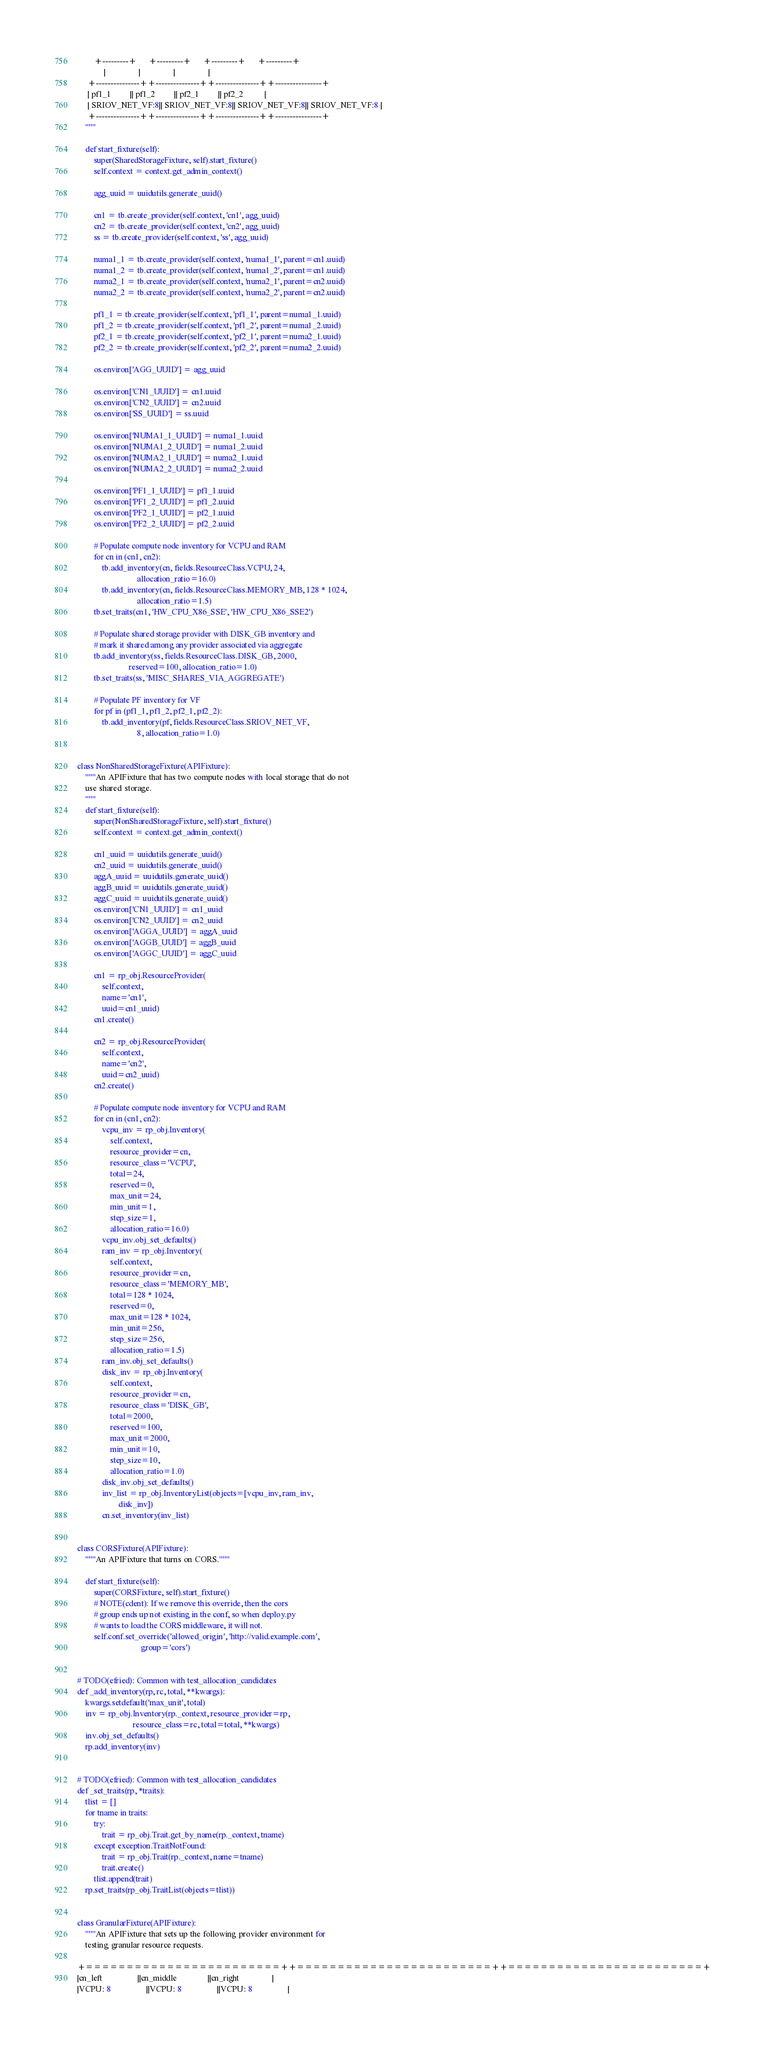Convert code to text. <code><loc_0><loc_0><loc_500><loc_500><_Python_>        +---------+      +---------+      +---------+      +---------+
             |                |                |                |
     +---------------++---------------++---------------++----------------+
     | pf1_1         || pf1_2         || pf2_1         || pf2_2          |
     | SRIOV_NET_VF:8|| SRIOV_NET_VF:8|| SRIOV_NET_VF:8|| SRIOV_NET_VF:8 |
     +---------------++---------------++---------------++----------------+
    """

    def start_fixture(self):
        super(SharedStorageFixture, self).start_fixture()
        self.context = context.get_admin_context()

        agg_uuid = uuidutils.generate_uuid()

        cn1 = tb.create_provider(self.context, 'cn1', agg_uuid)
        cn2 = tb.create_provider(self.context, 'cn2', agg_uuid)
        ss = tb.create_provider(self.context, 'ss', agg_uuid)

        numa1_1 = tb.create_provider(self.context, 'numa1_1', parent=cn1.uuid)
        numa1_2 = tb.create_provider(self.context, 'numa1_2', parent=cn1.uuid)
        numa2_1 = tb.create_provider(self.context, 'numa2_1', parent=cn2.uuid)
        numa2_2 = tb.create_provider(self.context, 'numa2_2', parent=cn2.uuid)

        pf1_1 = tb.create_provider(self.context, 'pf1_1', parent=numa1_1.uuid)
        pf1_2 = tb.create_provider(self.context, 'pf1_2', parent=numa1_2.uuid)
        pf2_1 = tb.create_provider(self.context, 'pf2_1', parent=numa2_1.uuid)
        pf2_2 = tb.create_provider(self.context, 'pf2_2', parent=numa2_2.uuid)

        os.environ['AGG_UUID'] = agg_uuid

        os.environ['CN1_UUID'] = cn1.uuid
        os.environ['CN2_UUID'] = cn2.uuid
        os.environ['SS_UUID'] = ss.uuid

        os.environ['NUMA1_1_UUID'] = numa1_1.uuid
        os.environ['NUMA1_2_UUID'] = numa1_2.uuid
        os.environ['NUMA2_1_UUID'] = numa2_1.uuid
        os.environ['NUMA2_2_UUID'] = numa2_2.uuid

        os.environ['PF1_1_UUID'] = pf1_1.uuid
        os.environ['PF1_2_UUID'] = pf1_2.uuid
        os.environ['PF2_1_UUID'] = pf2_1.uuid
        os.environ['PF2_2_UUID'] = pf2_2.uuid

        # Populate compute node inventory for VCPU and RAM
        for cn in (cn1, cn2):
            tb.add_inventory(cn, fields.ResourceClass.VCPU, 24,
                             allocation_ratio=16.0)
            tb.add_inventory(cn, fields.ResourceClass.MEMORY_MB, 128 * 1024,
                             allocation_ratio=1.5)
        tb.set_traits(cn1, 'HW_CPU_X86_SSE', 'HW_CPU_X86_SSE2')

        # Populate shared storage provider with DISK_GB inventory and
        # mark it shared among any provider associated via aggregate
        tb.add_inventory(ss, fields.ResourceClass.DISK_GB, 2000,
                         reserved=100, allocation_ratio=1.0)
        tb.set_traits(ss, 'MISC_SHARES_VIA_AGGREGATE')

        # Populate PF inventory for VF
        for pf in (pf1_1, pf1_2, pf2_1, pf2_2):
            tb.add_inventory(pf, fields.ResourceClass.SRIOV_NET_VF,
                             8, allocation_ratio=1.0)


class NonSharedStorageFixture(APIFixture):
    """An APIFixture that has two compute nodes with local storage that do not
    use shared storage.
    """
    def start_fixture(self):
        super(NonSharedStorageFixture, self).start_fixture()
        self.context = context.get_admin_context()

        cn1_uuid = uuidutils.generate_uuid()
        cn2_uuid = uuidutils.generate_uuid()
        aggA_uuid = uuidutils.generate_uuid()
        aggB_uuid = uuidutils.generate_uuid()
        aggC_uuid = uuidutils.generate_uuid()
        os.environ['CN1_UUID'] = cn1_uuid
        os.environ['CN2_UUID'] = cn2_uuid
        os.environ['AGGA_UUID'] = aggA_uuid
        os.environ['AGGB_UUID'] = aggB_uuid
        os.environ['AGGC_UUID'] = aggC_uuid

        cn1 = rp_obj.ResourceProvider(
            self.context,
            name='cn1',
            uuid=cn1_uuid)
        cn1.create()

        cn2 = rp_obj.ResourceProvider(
            self.context,
            name='cn2',
            uuid=cn2_uuid)
        cn2.create()

        # Populate compute node inventory for VCPU and RAM
        for cn in (cn1, cn2):
            vcpu_inv = rp_obj.Inventory(
                self.context,
                resource_provider=cn,
                resource_class='VCPU',
                total=24,
                reserved=0,
                max_unit=24,
                min_unit=1,
                step_size=1,
                allocation_ratio=16.0)
            vcpu_inv.obj_set_defaults()
            ram_inv = rp_obj.Inventory(
                self.context,
                resource_provider=cn,
                resource_class='MEMORY_MB',
                total=128 * 1024,
                reserved=0,
                max_unit=128 * 1024,
                min_unit=256,
                step_size=256,
                allocation_ratio=1.5)
            ram_inv.obj_set_defaults()
            disk_inv = rp_obj.Inventory(
                self.context,
                resource_provider=cn,
                resource_class='DISK_GB',
                total=2000,
                reserved=100,
                max_unit=2000,
                min_unit=10,
                step_size=10,
                allocation_ratio=1.0)
            disk_inv.obj_set_defaults()
            inv_list = rp_obj.InventoryList(objects=[vcpu_inv, ram_inv,
                    disk_inv])
            cn.set_inventory(inv_list)


class CORSFixture(APIFixture):
    """An APIFixture that turns on CORS."""

    def start_fixture(self):
        super(CORSFixture, self).start_fixture()
        # NOTE(cdent): If we remove this override, then the cors
        # group ends up not existing in the conf, so when deploy.py
        # wants to load the CORS middleware, it will not.
        self.conf.set_override('allowed_origin', 'http://valid.example.com',
                               group='cors')


# TODO(efried): Common with test_allocation_candidates
def _add_inventory(rp, rc, total, **kwargs):
    kwargs.setdefault('max_unit', total)
    inv = rp_obj.Inventory(rp._context, resource_provider=rp,
                           resource_class=rc, total=total, **kwargs)
    inv.obj_set_defaults()
    rp.add_inventory(inv)


# TODO(efried): Common with test_allocation_candidates
def _set_traits(rp, *traits):
    tlist = []
    for tname in traits:
        try:
            trait = rp_obj.Trait.get_by_name(rp._context, tname)
        except exception.TraitNotFound:
            trait = rp_obj.Trait(rp._context, name=tname)
            trait.create()
        tlist.append(trait)
    rp.set_traits(rp_obj.TraitList(objects=tlist))


class GranularFixture(APIFixture):
    """An APIFixture that sets up the following provider environment for
    testing granular resource requests.

+========================++========================++========================+
|cn_left                 ||cn_middle               ||cn_right                |
|VCPU: 8                 ||VCPU: 8                 ||VCPU: 8                 |</code> 